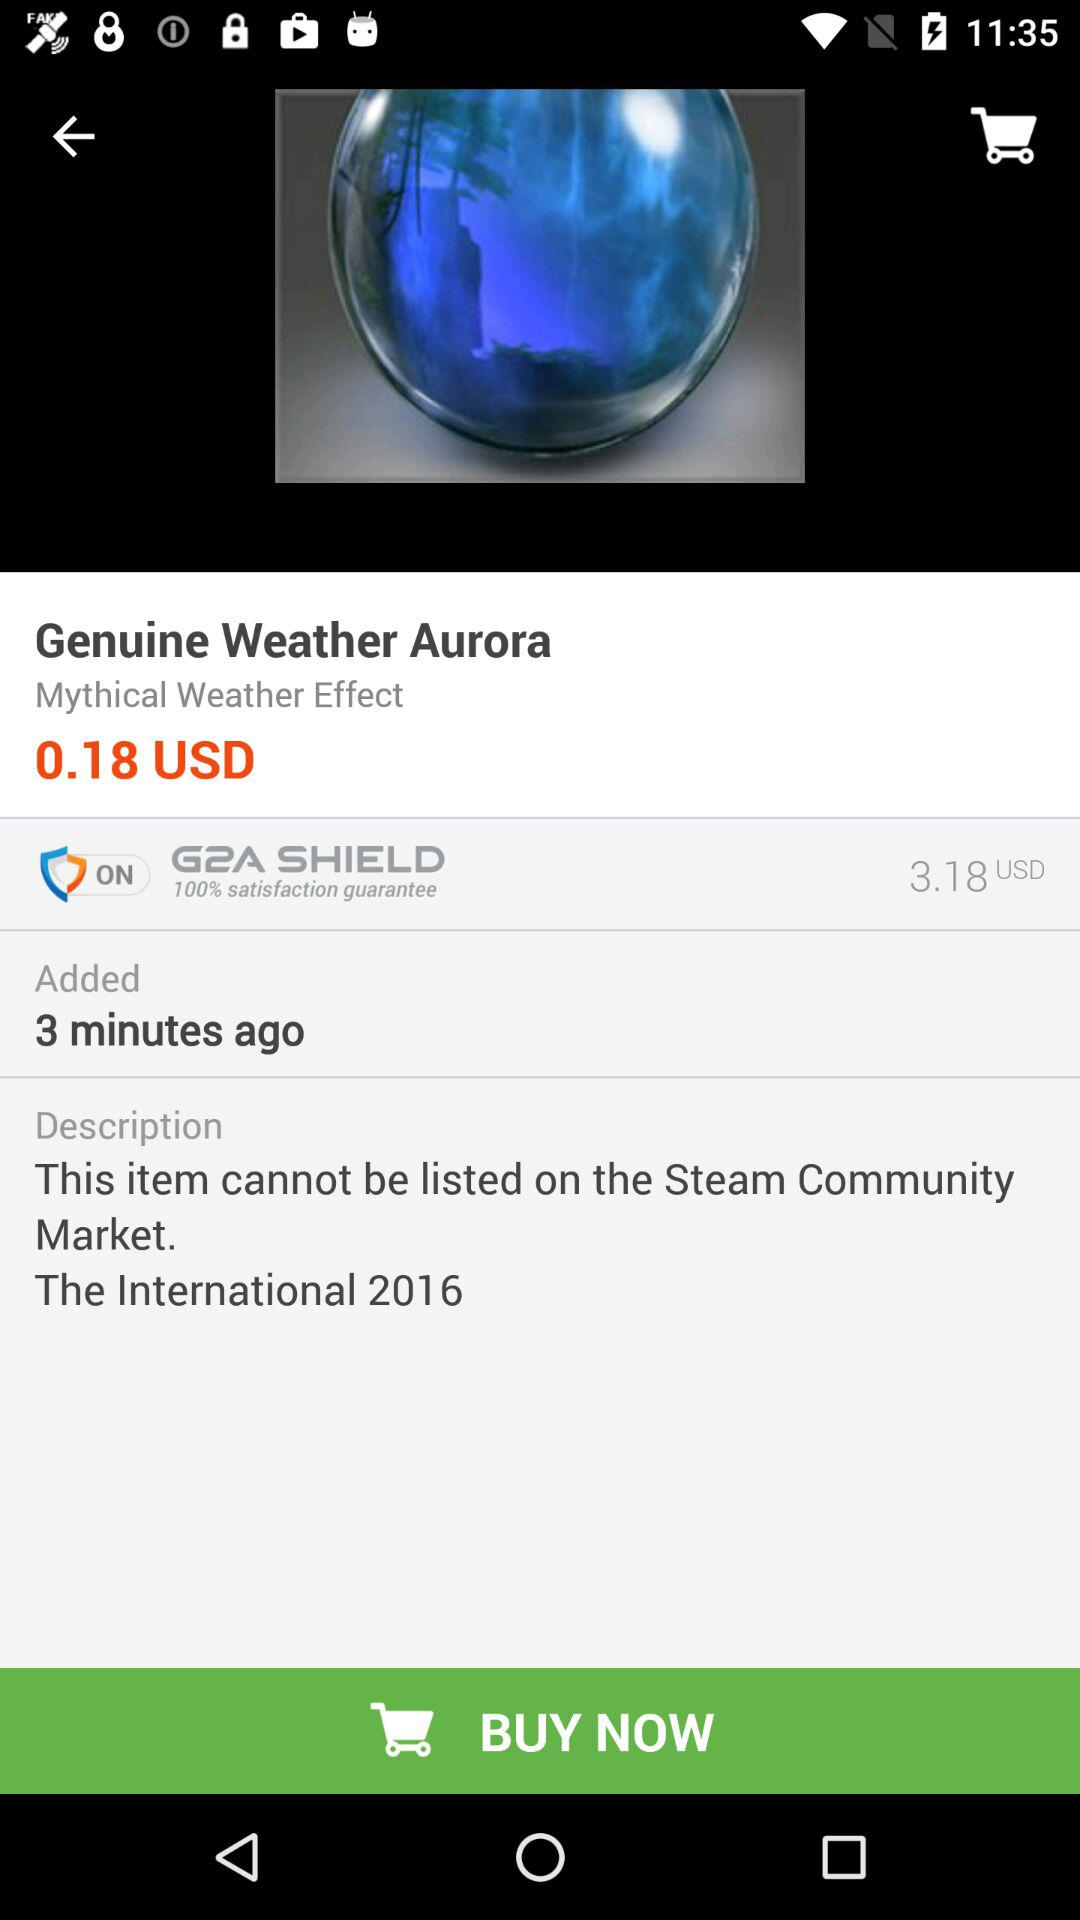How many minutes ago was this item added?
Answer the question using a single word or phrase. 3 